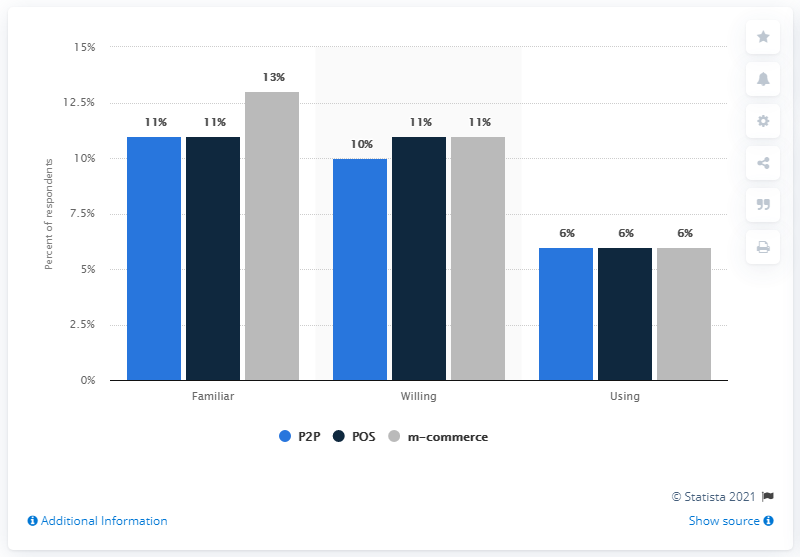Outline some significant characteristics in this image. The lowest value in the blue bar is 6. The sum of the highest and lowest values of the blue bar is 17. In 2012, 11% of Hong Kong consumers were familiar with mobile payments at the point of sale. 